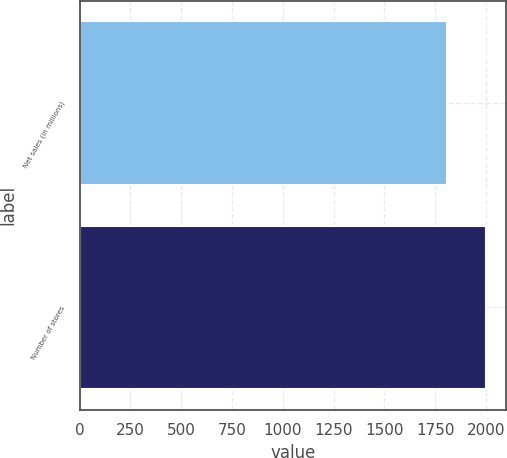<chart> <loc_0><loc_0><loc_500><loc_500><bar_chart><fcel>Net sales (in millions)<fcel>Number of stores<nl><fcel>1809.3<fcel>2000<nl></chart> 